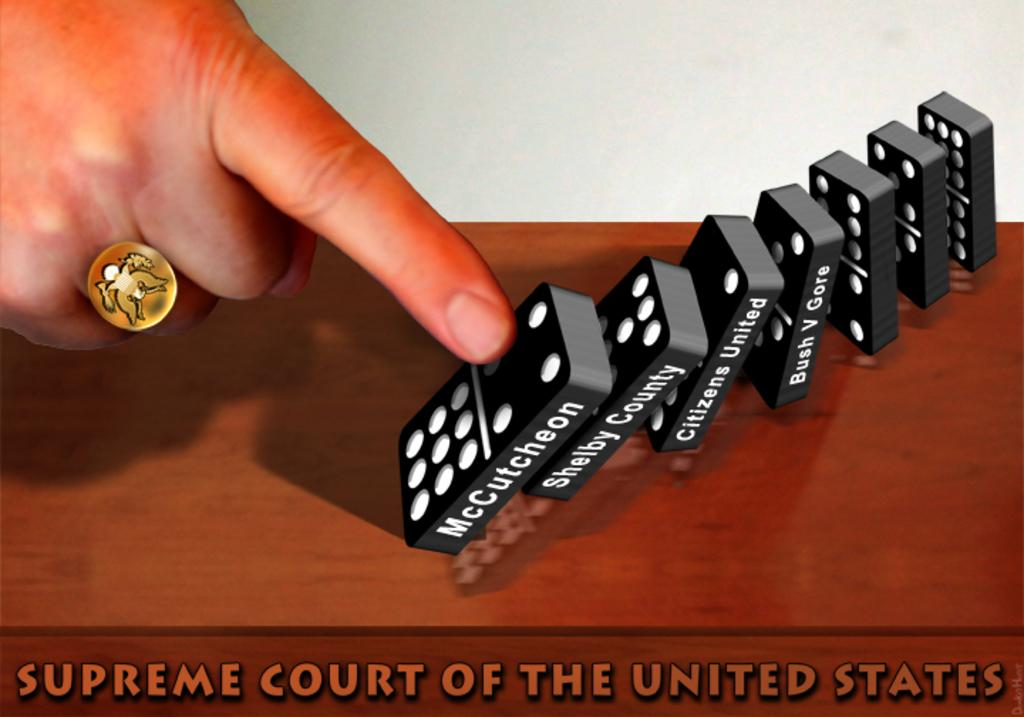<image>
Give a short and clear explanation of the subsequent image. A person doing a demonstration with dominos to the Supreme Court of the United States. 